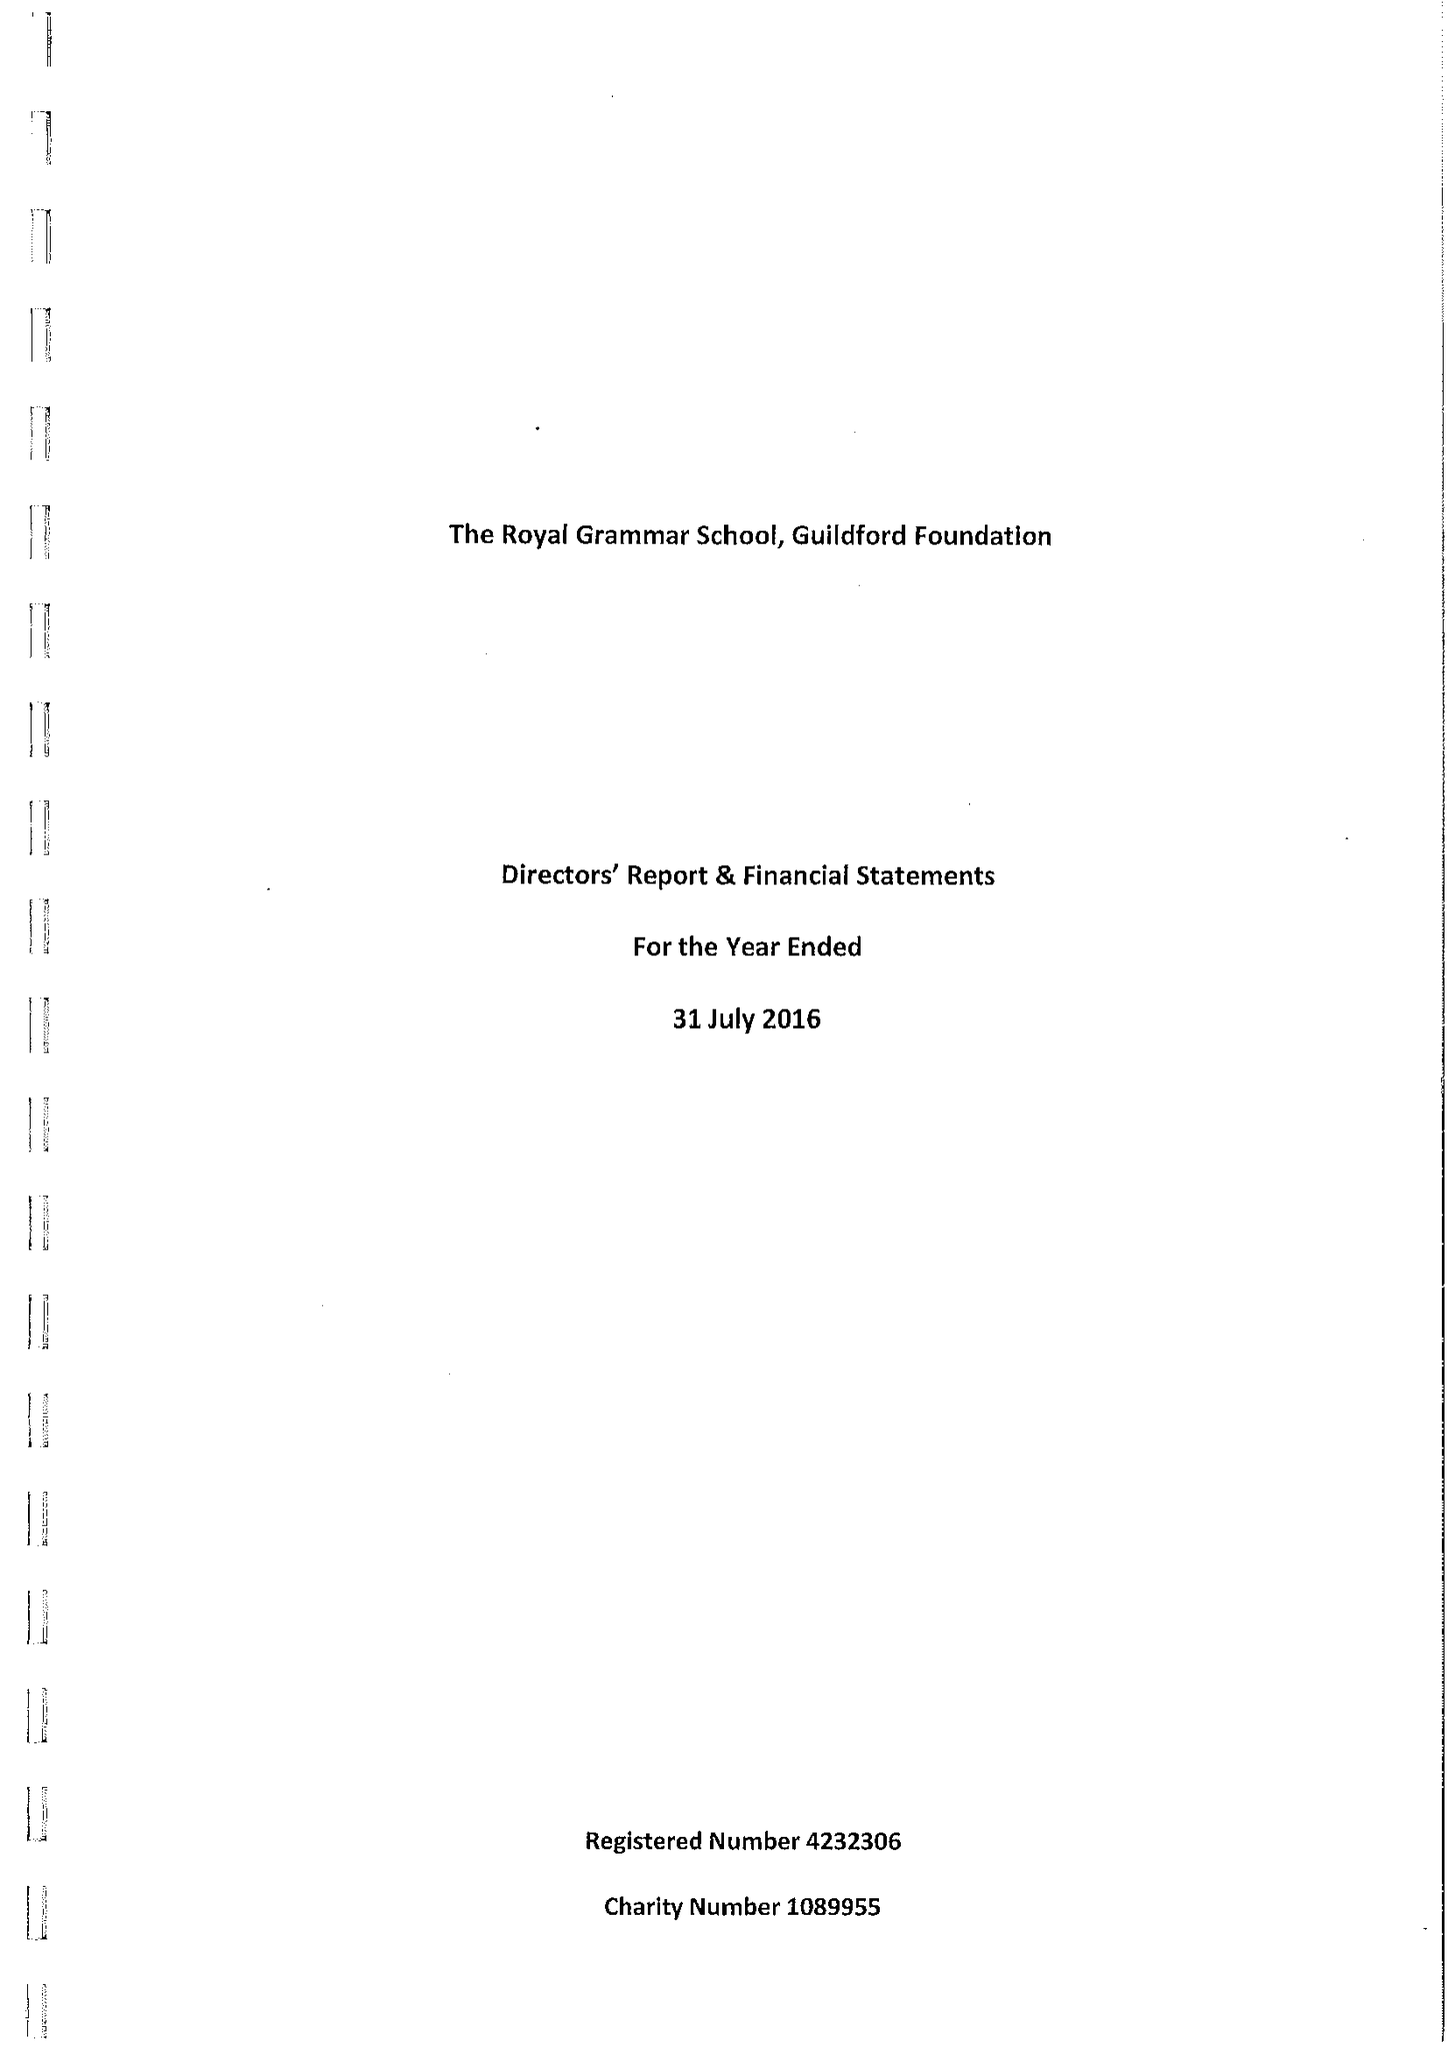What is the value for the income_annually_in_british_pounds?
Answer the question using a single word or phrase. 206667.00 